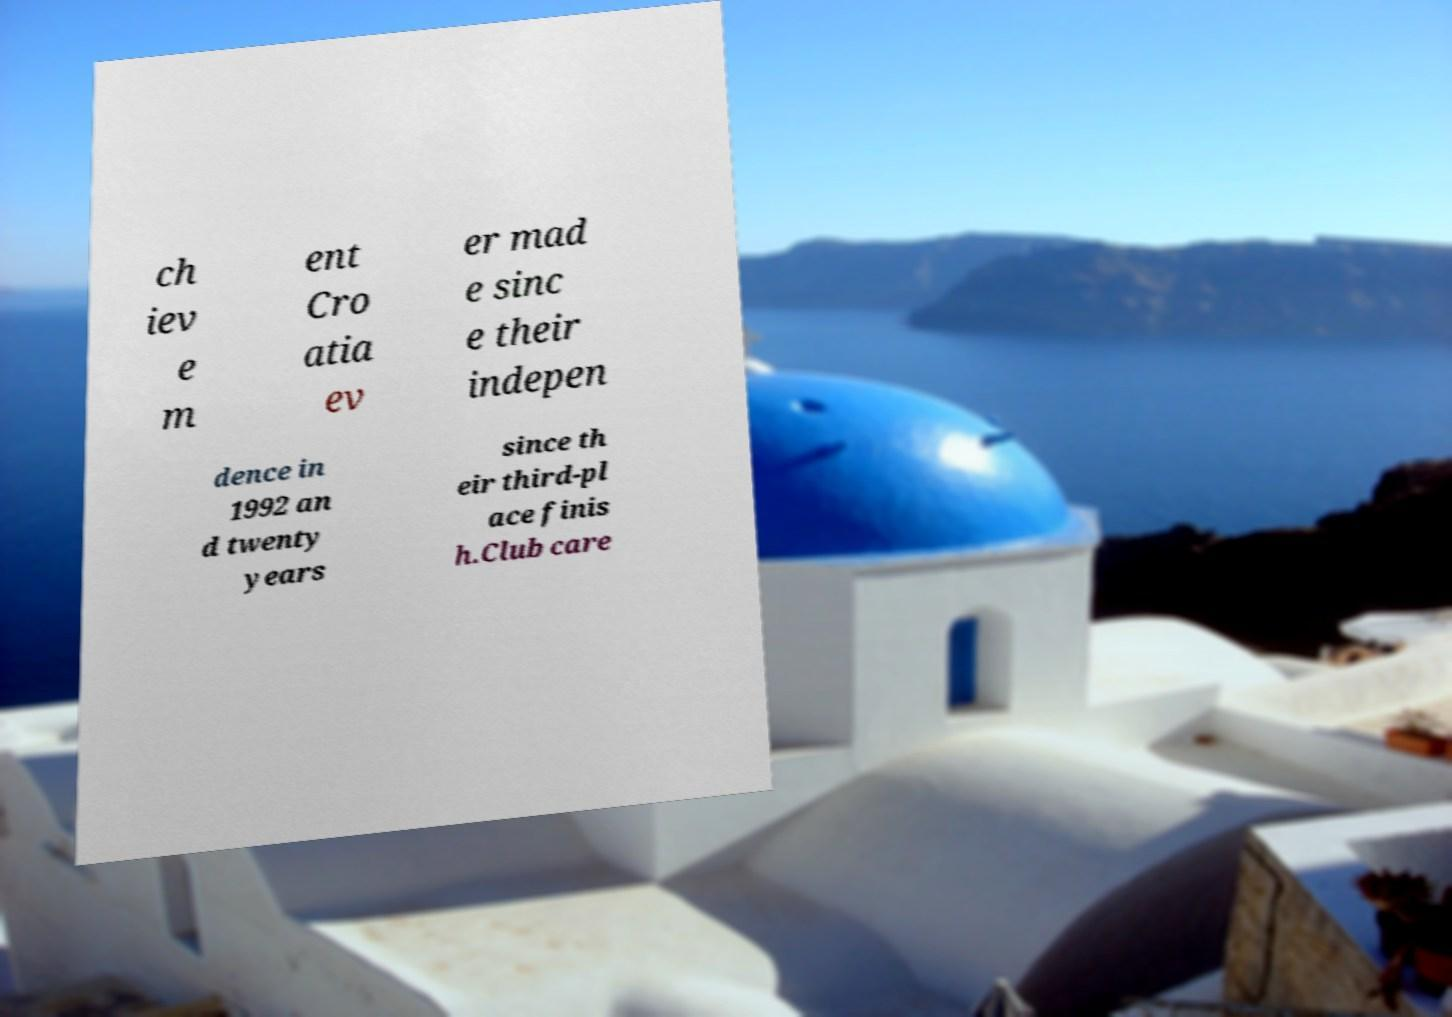There's text embedded in this image that I need extracted. Can you transcribe it verbatim? ch iev e m ent Cro atia ev er mad e sinc e their indepen dence in 1992 an d twenty years since th eir third-pl ace finis h.Club care 